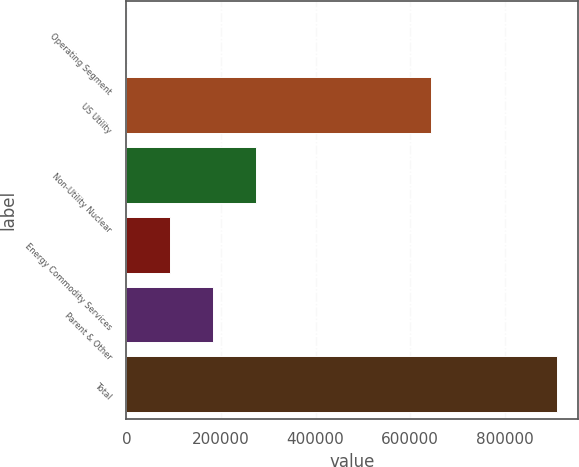Convert chart to OTSL. <chart><loc_0><loc_0><loc_500><loc_500><bar_chart><fcel>Operating Segment<fcel>US Utility<fcel>Non-Utility Nuclear<fcel>Energy Commodity Services<fcel>Parent & Other<fcel>Total<nl><fcel>2004<fcel>643408<fcel>274260<fcel>92756<fcel>183508<fcel>909524<nl></chart> 